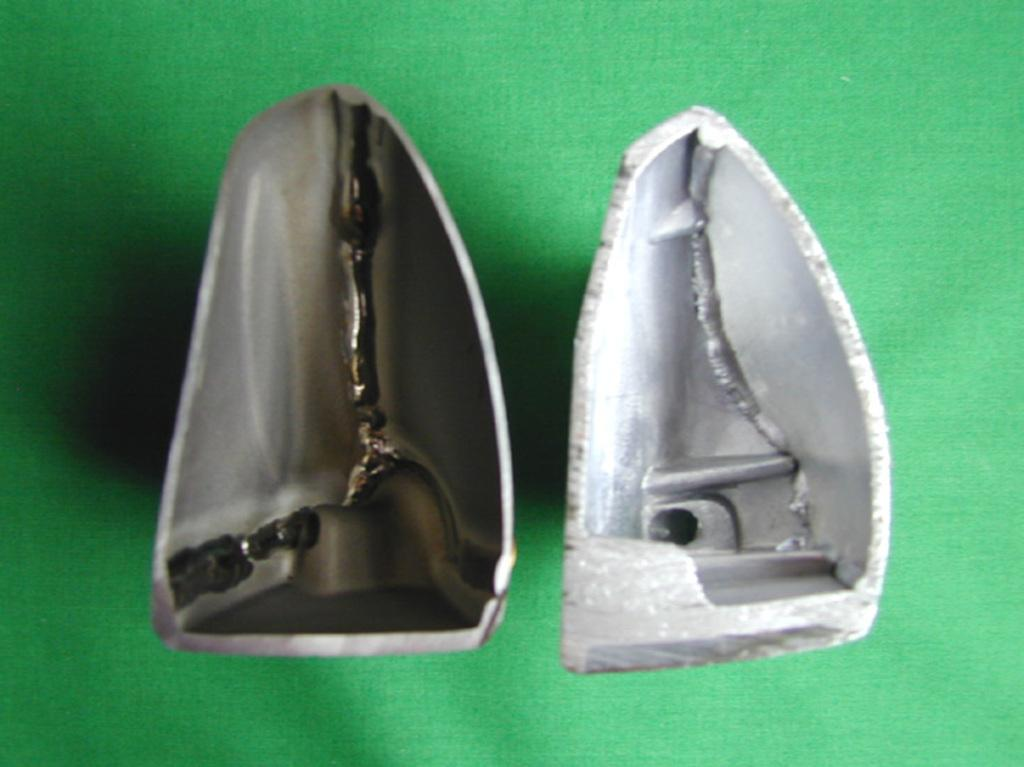What objects are depicted as broken in the image? There are two broken metal pieces in the image. What is the color of the floor in the image? The floor in the image is green. What type of advice can be seen written on the metal pieces in the image? There is no advice visible on the metal pieces in the image; they are simply depicted as broken. What type of coal can be seen stored in the image? There is no coal present in the image. What type of harbor can be seen in the image? There is no harbor present in the image. 